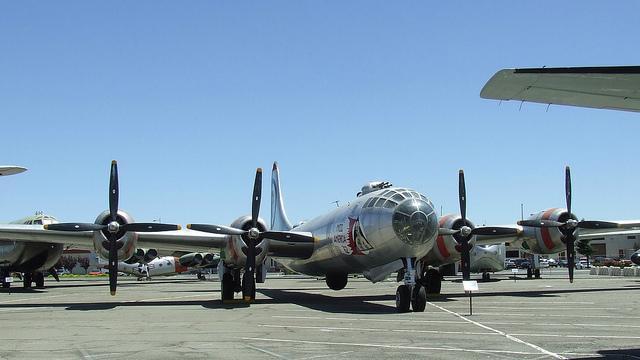How many propellers?
Give a very brief answer. 4. How many propellers does the plane have?
Give a very brief answer. 4. How many airplanes are in the picture?
Give a very brief answer. 7. 